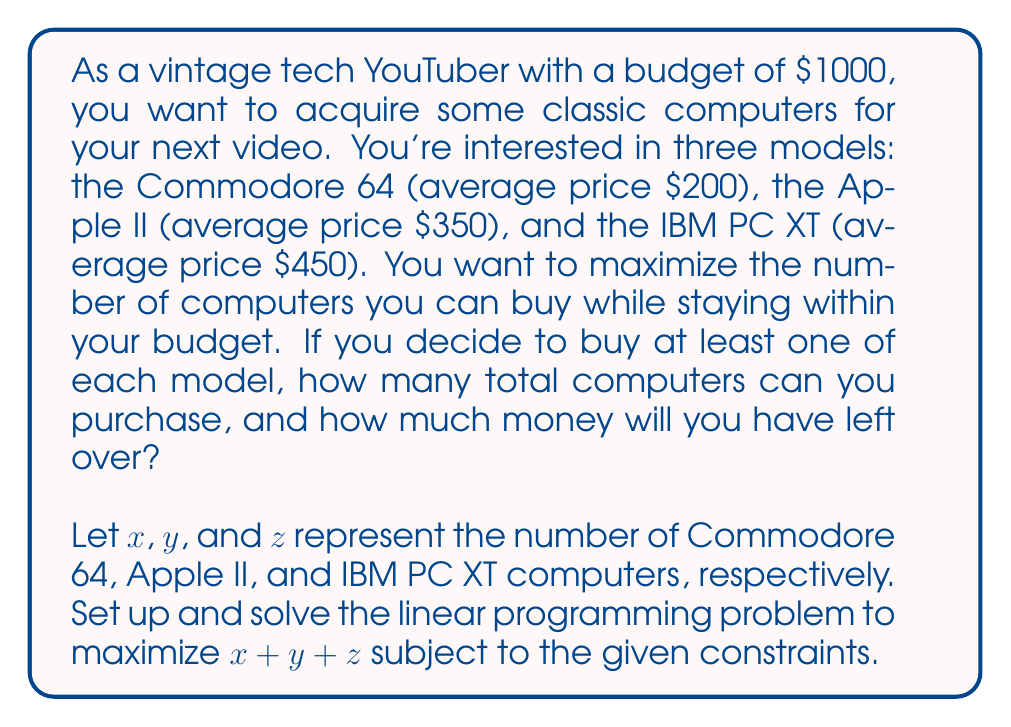Provide a solution to this math problem. To solve this problem, we need to set up a linear programming model and use the simplex method or integer programming techniques. However, given the small scale of the problem, we can solve it through logical deduction.

1) First, let's set up the constraints:
   $200x + 350y + 450z \leq 1000$ (budget constraint)
   $x \geq 1$, $y \geq 1$, $z \geq 1$ (at least one of each model)
   $x$, $y$, $z$ are integers

2) Given that we must buy at least one of each model, let's start with that:
   1 Commodore 64 + 1 Apple II + 1 IBM PC XT = $200 + $350 + $450 = $1000

3) This exactly meets our budget constraint, so we can't buy any more computers.

4) Therefore, the maximum number of computers we can buy is:
   $x + y + z = 1 + 1 + 1 = 3$

5) The amount of money left over is:
   $1000 - (200 + 350 + 450) = $0$

This solution satisfies all constraints and maximizes the number of computers within the given budget.
Answer: The maximum number of computers that can be purchased is 3 (1 Commodore 64, 1 Apple II, and 1 IBM PC XT), with $0 left over. 